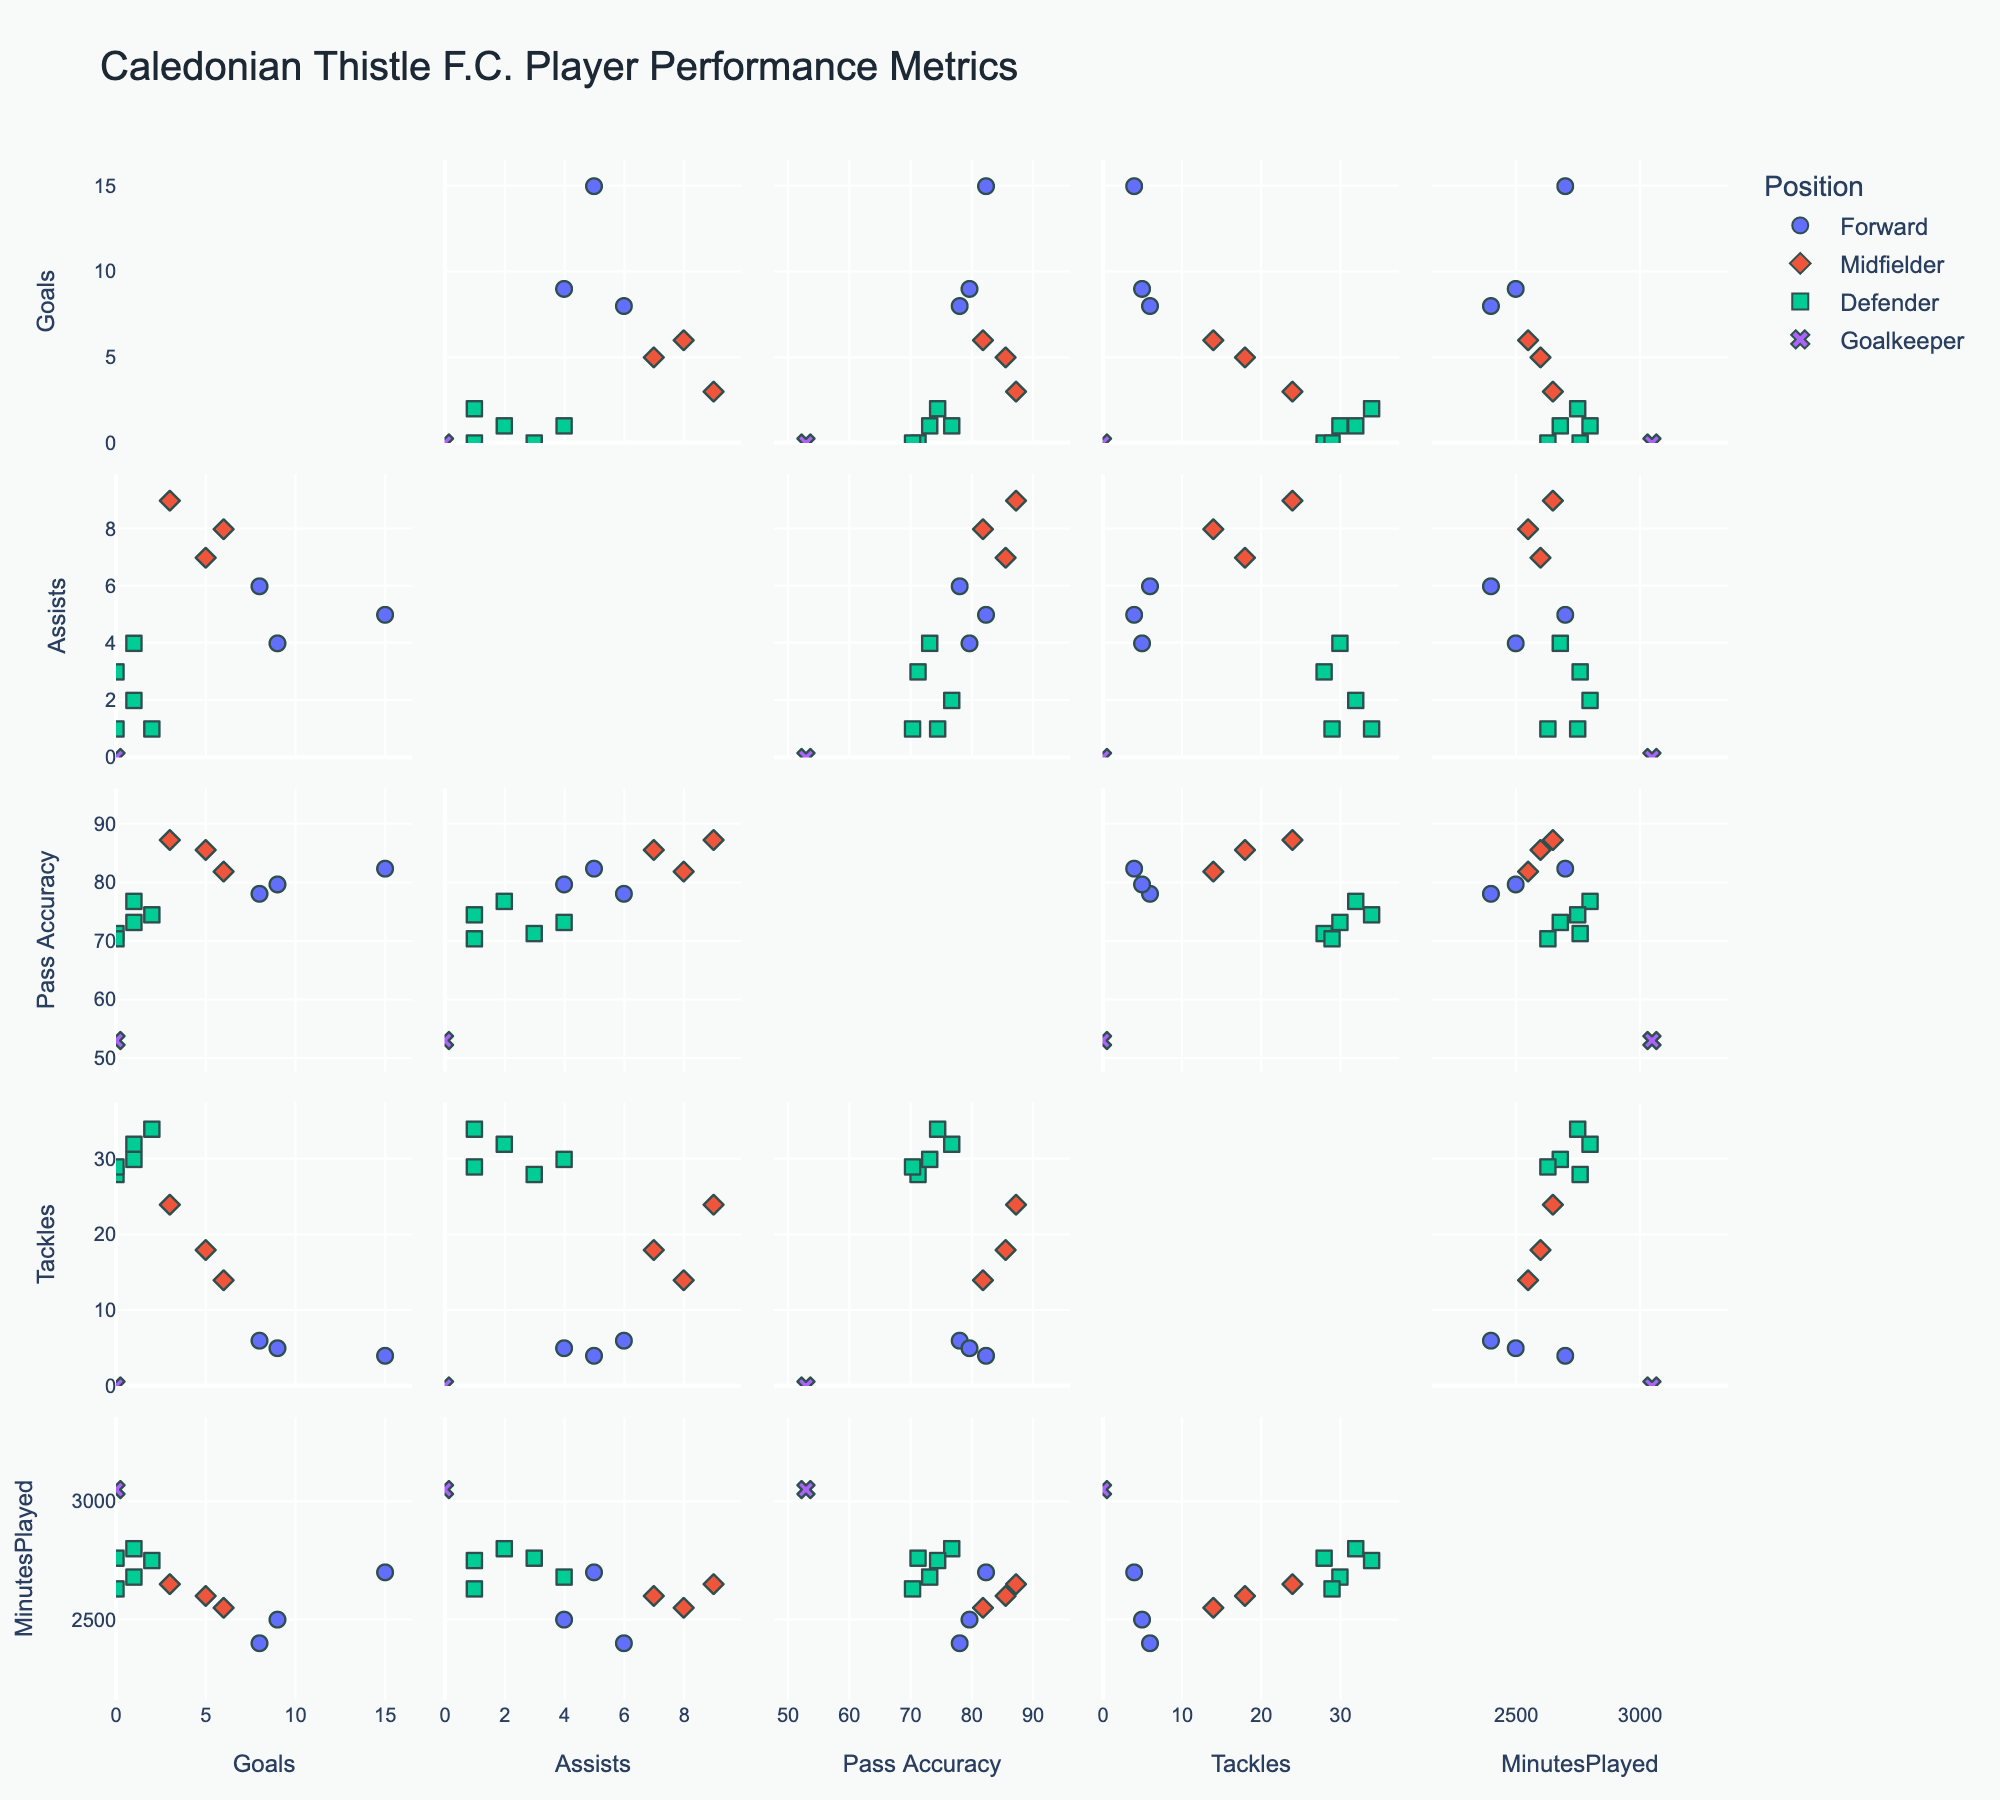how many data points represent midfielders? There are 3 midfielders in the dataset: Roddy MacGregor, Scott Allardice, and Aaron Doran. Each represents one data point.
Answer: 3 which player has the highest pass accuracy? By looking at the Pass Accuracy values, Scott Allardice has the highest value of 87.3%.
Answer: Scott Allardice Is there a correlation between goals and minutes played for forwards? By inspecting the scatter matrix plot of Goals vs. Minutes Played for forwards, we can observe if there's any visible trend between these variables for forwards. Because Billy Mckay and Tom Walsh, who have high goals, also have high minutes played, they exhibit a positive correlation.
Answer: Yes What is the range of tackles made by defenders? By checking the Tackles axis for defenders, the minimum value is 28 and the maximum is 34.
Answer: 28 to 34 Who has the most assists among defenders? By examining the Assists axis for defenders, Cameron Harper has the highest value with 4 assists.
Answer: Cameron Harper Is there any player with more than 10 goals and 80+ pass accuracy? By inspecting the matrix, only Billy Mckay has more than 10 goals (15) and his pass accuracy is above 80 (82.4%).
Answer: Billy Mckay What’s the relationship between tackles and minutes played for midfielders? By looking at the scatter matrix plot of Tackles vs. Minutes Played for midfielders, we notice that as the number of minutes played increases, the number of tackles also increases, showing a positive correlation.
Answer: Positive correlation Which position shows the widest range in pass accuracy? By comparing the range of Pass Accuracy values for each position, defenders have the widest range, from the lowest (70.4) to close to the top values (76.8).
Answer: Defenders How do the goals of forwards compare with midfielders? By comparing the goals axis for both forwards and midfielders, forwards like Billy Mckay and Tom Walsh have higher goal counts (15 and 9) compared to midfielders who have lower goal counts (6, 5, and 3).
Answer: Forwards have higher goals than midfielders What pair of metrics have the strongest relationship for defenders? Observing the scatter matrix, Tackles and Minutes Played for defenders display the tightest clustering and visible positive correlation.
Answer: Tackles vs. Minutes Played 